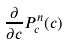<formula> <loc_0><loc_0><loc_500><loc_500>\frac { \partial } { \partial c } P _ { c } ^ { n } ( c )</formula> 